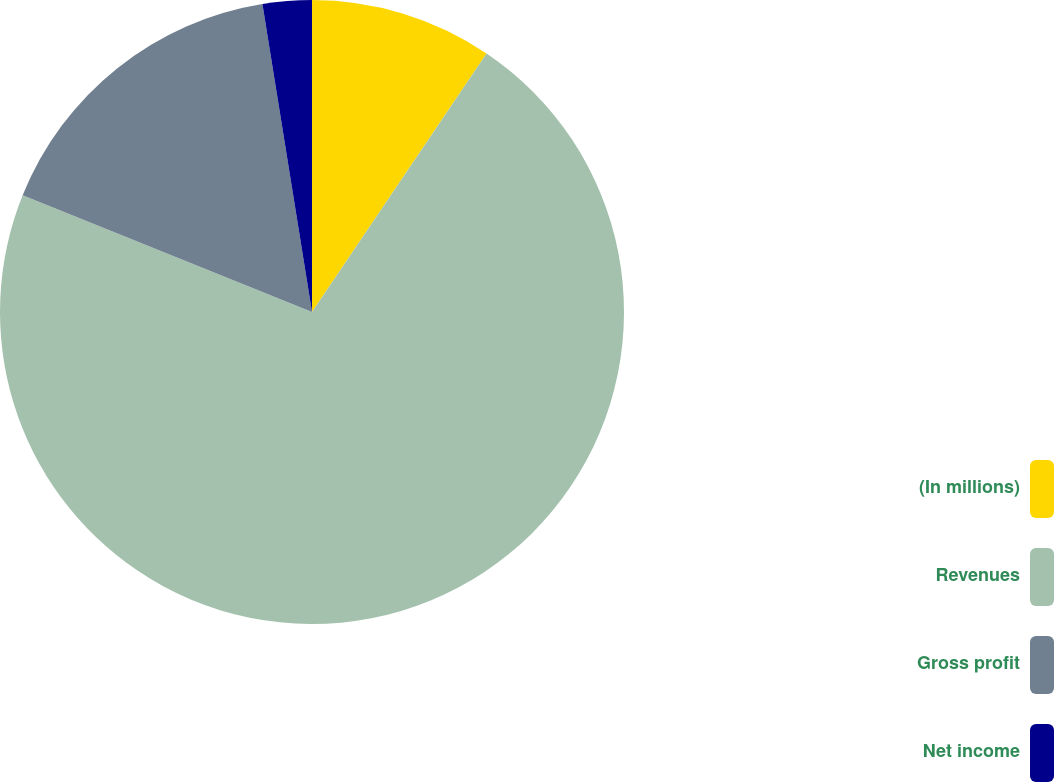Convert chart to OTSL. <chart><loc_0><loc_0><loc_500><loc_500><pie_chart><fcel>(In millions)<fcel>Revenues<fcel>Gross profit<fcel>Net income<nl><fcel>9.45%<fcel>71.66%<fcel>16.36%<fcel>2.54%<nl></chart> 